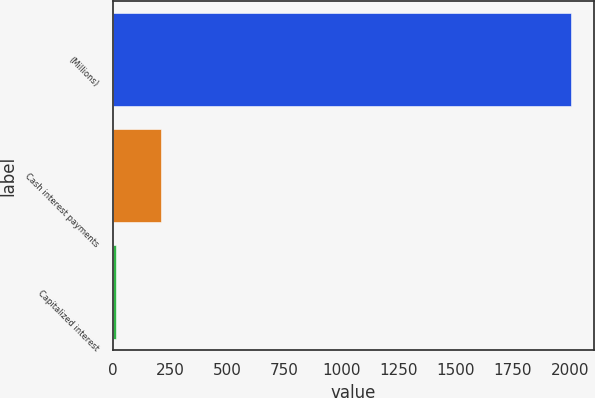<chart> <loc_0><loc_0><loc_500><loc_500><bar_chart><fcel>(Millions)<fcel>Cash interest payments<fcel>Capitalized interest<nl><fcel>2005<fcel>211.3<fcel>12<nl></chart> 